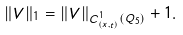<formula> <loc_0><loc_0><loc_500><loc_500>\| V \| _ { 1 } = \| V \| _ { C ^ { 1 } _ { ( x , t ) } ( Q _ { 5 } ) } + 1 .</formula> 